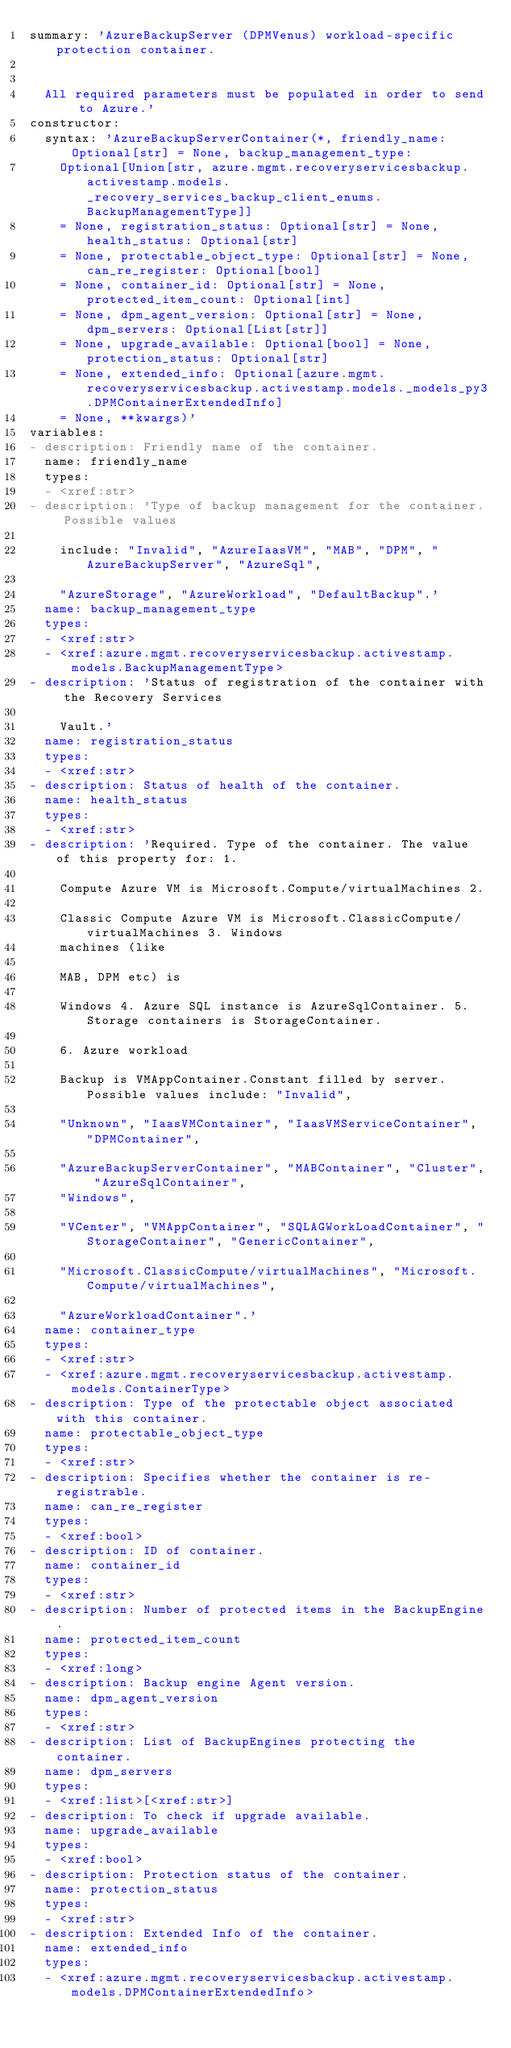Convert code to text. <code><loc_0><loc_0><loc_500><loc_500><_YAML_>summary: 'AzureBackupServer (DPMVenus) workload-specific protection container.


  All required parameters must be populated in order to send to Azure.'
constructor:
  syntax: 'AzureBackupServerContainer(*, friendly_name: Optional[str] = None, backup_management_type:
    Optional[Union[str, azure.mgmt.recoveryservicesbackup.activestamp.models._recovery_services_backup_client_enums.BackupManagementType]]
    = None, registration_status: Optional[str] = None, health_status: Optional[str]
    = None, protectable_object_type: Optional[str] = None, can_re_register: Optional[bool]
    = None, container_id: Optional[str] = None, protected_item_count: Optional[int]
    = None, dpm_agent_version: Optional[str] = None, dpm_servers: Optional[List[str]]
    = None, upgrade_available: Optional[bool] = None, protection_status: Optional[str]
    = None, extended_info: Optional[azure.mgmt.recoveryservicesbackup.activestamp.models._models_py3.DPMContainerExtendedInfo]
    = None, **kwargs)'
variables:
- description: Friendly name of the container.
  name: friendly_name
  types:
  - <xref:str>
- description: 'Type of backup management for the container. Possible values

    include: "Invalid", "AzureIaasVM", "MAB", "DPM", "AzureBackupServer", "AzureSql",

    "AzureStorage", "AzureWorkload", "DefaultBackup".'
  name: backup_management_type
  types:
  - <xref:str>
  - <xref:azure.mgmt.recoveryservicesbackup.activestamp.models.BackupManagementType>
- description: 'Status of registration of the container with the Recovery Services

    Vault.'
  name: registration_status
  types:
  - <xref:str>
- description: Status of health of the container.
  name: health_status
  types:
  - <xref:str>
- description: 'Required. Type of the container. The value of this property for: 1.

    Compute Azure VM is Microsoft.Compute/virtualMachines 2.

    Classic Compute Azure VM is Microsoft.ClassicCompute/virtualMachines 3. Windows
    machines (like

    MAB, DPM etc) is

    Windows 4. Azure SQL instance is AzureSqlContainer. 5. Storage containers is StorageContainer.

    6. Azure workload

    Backup is VMAppContainer.Constant filled by server. Possible values include: "Invalid",

    "Unknown", "IaasVMContainer", "IaasVMServiceContainer", "DPMContainer",

    "AzureBackupServerContainer", "MABContainer", "Cluster", "AzureSqlContainer",
    "Windows",

    "VCenter", "VMAppContainer", "SQLAGWorkLoadContainer", "StorageContainer", "GenericContainer",

    "Microsoft.ClassicCompute/virtualMachines", "Microsoft.Compute/virtualMachines",

    "AzureWorkloadContainer".'
  name: container_type
  types:
  - <xref:str>
  - <xref:azure.mgmt.recoveryservicesbackup.activestamp.models.ContainerType>
- description: Type of the protectable object associated with this container.
  name: protectable_object_type
  types:
  - <xref:str>
- description: Specifies whether the container is re-registrable.
  name: can_re_register
  types:
  - <xref:bool>
- description: ID of container.
  name: container_id
  types:
  - <xref:str>
- description: Number of protected items in the BackupEngine.
  name: protected_item_count
  types:
  - <xref:long>
- description: Backup engine Agent version.
  name: dpm_agent_version
  types:
  - <xref:str>
- description: List of BackupEngines protecting the container.
  name: dpm_servers
  types:
  - <xref:list>[<xref:str>]
- description: To check if upgrade available.
  name: upgrade_available
  types:
  - <xref:bool>
- description: Protection status of the container.
  name: protection_status
  types:
  - <xref:str>
- description: Extended Info of the container.
  name: extended_info
  types:
  - <xref:azure.mgmt.recoveryservicesbackup.activestamp.models.DPMContainerExtendedInfo>
</code> 